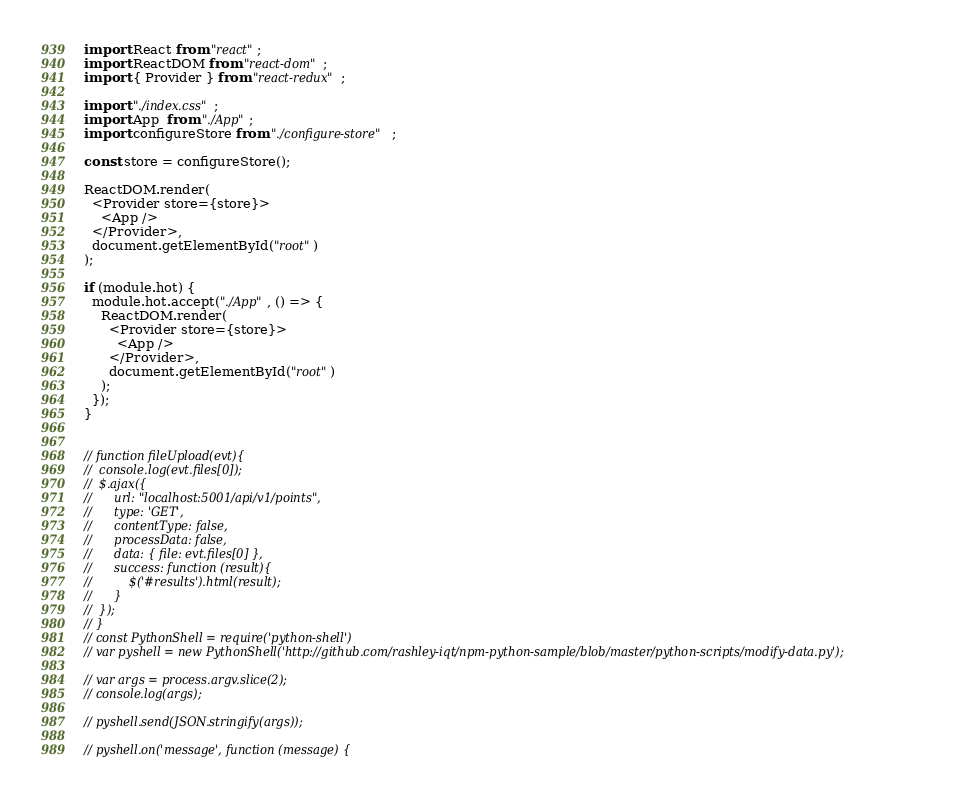Convert code to text. <code><loc_0><loc_0><loc_500><loc_500><_JavaScript_>import React from "react";
import ReactDOM from "react-dom";
import { Provider } from "react-redux";

import "./index.css";
import App  from "./App";
import configureStore from "./configure-store";

const store = configureStore();

ReactDOM.render(
  <Provider store={store}>
    <App />
  </Provider>,
  document.getElementById("root")
);

if (module.hot) {
  module.hot.accept("./App", () => {
    ReactDOM.render(
      <Provider store={store}>
        <App />
      </Provider>,
      document.getElementById("root")
    );
  });
}


// function fileUpload(evt){
// 	console.log(evt.files[0]);
// 	$.ajax({
// 		url: "localhost:5001/api/v1/points",
// 		type: 'GET',
// 		contentType: false,
// 		processData: false,
// 		data: { file: evt.files[0] },
// 		success: function (result){
// 			$('#results').html(result);
// 		}
// 	});
// }
// const PythonShell = require('python-shell')
// var pyshell = new PythonShell('http://github.com/rashley-iqt/npm-python-sample/blob/master/python-scripts/modify-data.py');

// var args = process.argv.slice(2);
// console.log(args);

// pyshell.send(JSON.stringify(args));

// pyshell.on('message', function (message) {</code> 